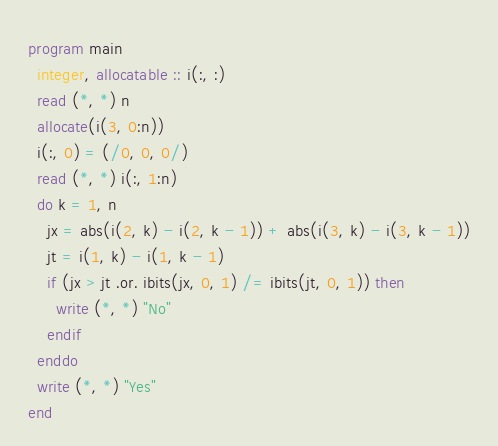<code> <loc_0><loc_0><loc_500><loc_500><_FORTRAN_>program main
  integer, allocatable :: i(:, :)
  read (*, *) n
  allocate(i(3, 0:n))
  i(:, 0) = (/0, 0, 0/)
  read (*, *) i(:, 1:n)
  do k = 1, n
    jx = abs(i(2, k) - i(2, k - 1)) + abs(i(3, k) - i(3, k - 1))
    jt = i(1, k) - i(1, k - 1)
    if (jx > jt .or. ibits(jx, 0, 1) /= ibits(jt, 0, 1)) then
      write (*, *) "No"
    endif
  enddo
  write (*, *) "Yes"
end
</code> 